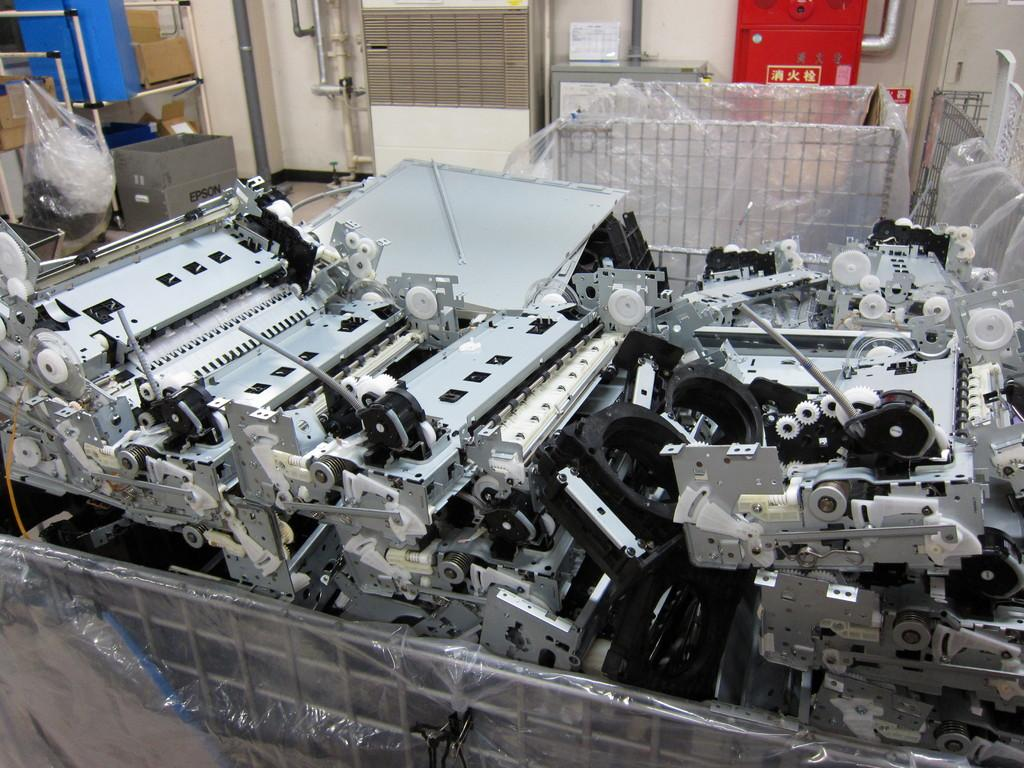What can be seen in the image? There are machines in the image, which are on an object. What materials are visible behind the machines? Steel items and cardboard boxes are present behind the machines, along with pipes. What is the background of the image? There is a wall in the background of the image, as well as other unspecified things. What are the giants discussing in the image? There are no giants present in the image, so there is no discussion to be observed. 